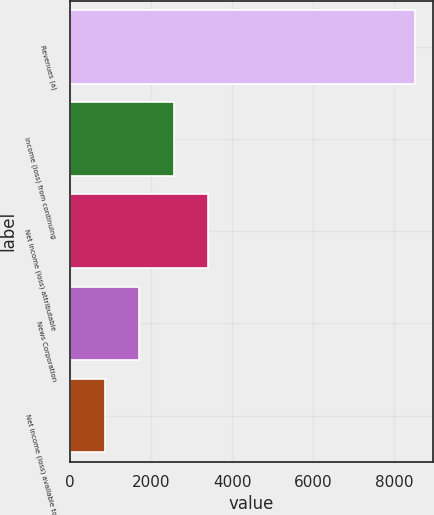Convert chart. <chart><loc_0><loc_0><loc_500><loc_500><bar_chart><fcel>Revenues (a)<fcel>Income (loss) from continuing<fcel>Net income (loss) attributable<fcel>News Corporation<fcel>Net income (loss) available to<nl><fcel>8524<fcel>2557.37<fcel>3409.74<fcel>1705<fcel>852.63<nl></chart> 